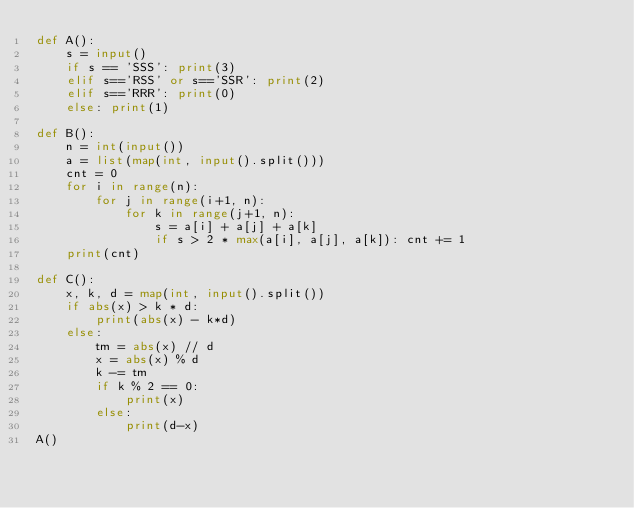Convert code to text. <code><loc_0><loc_0><loc_500><loc_500><_Python_>def A():
    s = input()
    if s == 'SSS': print(3)
    elif s=='RSS' or s=='SSR': print(2)
    elif s=='RRR': print(0)
    else: print(1)

def B():
    n = int(input())
    a = list(map(int, input().split()))
    cnt = 0
    for i in range(n):
        for j in range(i+1, n):
            for k in range(j+1, n):
                s = a[i] + a[j] + a[k]
                if s > 2 * max(a[i], a[j], a[k]): cnt += 1
    print(cnt)

def C():
    x, k, d = map(int, input().split())
    if abs(x) > k * d:
        print(abs(x) - k*d)
    else:
        tm = abs(x) // d
        x = abs(x) % d
        k -= tm
        if k % 2 == 0:
            print(x)
        else:
            print(d-x)
A()
</code> 